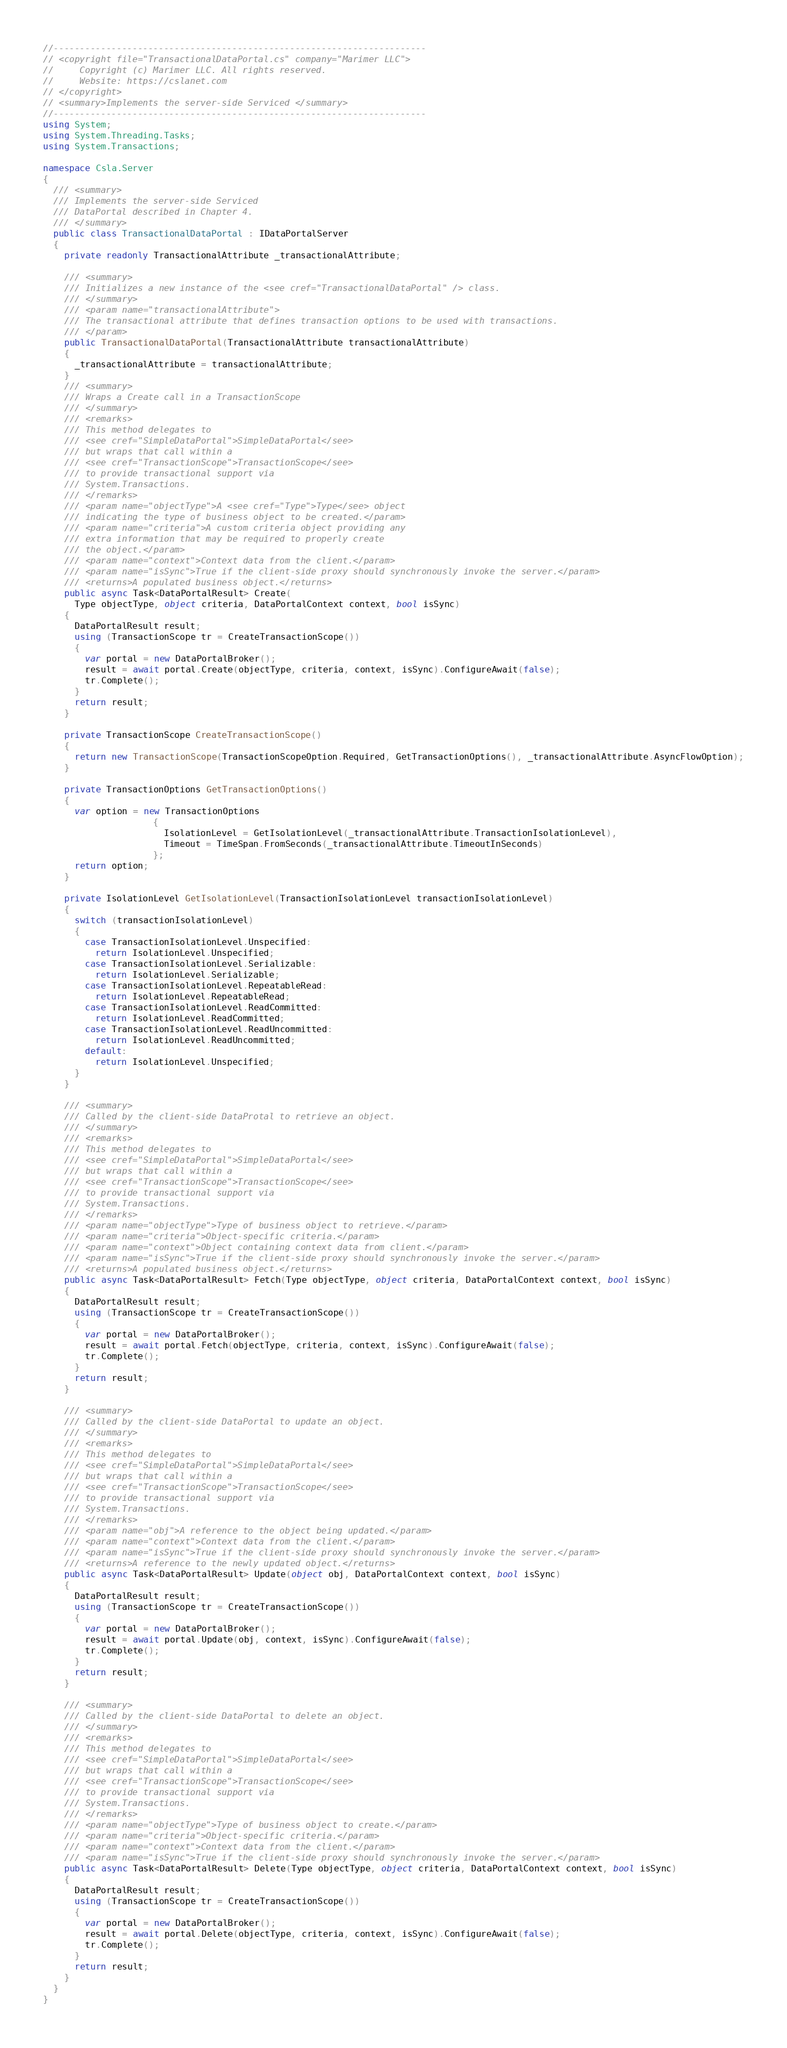Convert code to text. <code><loc_0><loc_0><loc_500><loc_500><_C#_>//-----------------------------------------------------------------------
// <copyright file="TransactionalDataPortal.cs" company="Marimer LLC">
//     Copyright (c) Marimer LLC. All rights reserved.
//     Website: https://cslanet.com
// </copyright>
// <summary>Implements the server-side Serviced </summary>
//-----------------------------------------------------------------------
using System;
using System.Threading.Tasks;
using System.Transactions;

namespace Csla.Server
{
  /// <summary>
  /// Implements the server-side Serviced 
  /// DataPortal described in Chapter 4.
  /// </summary>
  public class TransactionalDataPortal : IDataPortalServer
  {
    private readonly TransactionalAttribute _transactionalAttribute;

    /// <summary>
    /// Initializes a new instance of the <see cref="TransactionalDataPortal" /> class.
    /// </summary>
    /// <param name="transactionalAttribute">
    /// The transactional attribute that defines transaction options to be used with transactions.
    /// </param>
    public TransactionalDataPortal(TransactionalAttribute transactionalAttribute)
    {
      _transactionalAttribute = transactionalAttribute;
    }
    /// <summary>
    /// Wraps a Create call in a TransactionScope
    /// </summary>
    /// <remarks>
    /// This method delegates to 
    /// <see cref="SimpleDataPortal">SimpleDataPortal</see>
    /// but wraps that call within a
    /// <see cref="TransactionScope">TransactionScope</see>
    /// to provide transactional support via
    /// System.Transactions.
    /// </remarks>
    /// <param name="objectType">A <see cref="Type">Type</see> object
    /// indicating the type of business object to be created.</param>
    /// <param name="criteria">A custom criteria object providing any
    /// extra information that may be required to properly create
    /// the object.</param>
    /// <param name="context">Context data from the client.</param>
    /// <param name="isSync">True if the client-side proxy should synchronously invoke the server.</param>
    /// <returns>A populated business object.</returns>
    public async Task<DataPortalResult> Create(
      Type objectType, object criteria, DataPortalContext context, bool isSync)
    {
      DataPortalResult result;
      using (TransactionScope tr = CreateTransactionScope())
      {
        var portal = new DataPortalBroker();
        result = await portal.Create(objectType, criteria, context, isSync).ConfigureAwait(false);
        tr.Complete();
      }
      return result;
    }

    private TransactionScope CreateTransactionScope()
    {
      return new TransactionScope(TransactionScopeOption.Required, GetTransactionOptions(), _transactionalAttribute.AsyncFlowOption);
    }

    private TransactionOptions GetTransactionOptions()
    {
      var option = new TransactionOptions
                     {
                       IsolationLevel = GetIsolationLevel(_transactionalAttribute.TransactionIsolationLevel),
                       Timeout = TimeSpan.FromSeconds(_transactionalAttribute.TimeoutInSeconds)
                     };
      return option;
    }

    private IsolationLevel GetIsolationLevel(TransactionIsolationLevel transactionIsolationLevel)
    {
      switch (transactionIsolationLevel)
      {
        case TransactionIsolationLevel.Unspecified:
          return IsolationLevel.Unspecified;
        case TransactionIsolationLevel.Serializable:
          return IsolationLevel.Serializable;
        case TransactionIsolationLevel.RepeatableRead:
          return IsolationLevel.RepeatableRead;
        case TransactionIsolationLevel.ReadCommitted:
          return IsolationLevel.ReadCommitted;
        case TransactionIsolationLevel.ReadUncommitted:
          return IsolationLevel.ReadUncommitted;
        default:
          return IsolationLevel.Unspecified;
      }
    }

    /// <summary>
    /// Called by the client-side DataProtal to retrieve an object.
    /// </summary>
    /// <remarks>
    /// This method delegates to 
    /// <see cref="SimpleDataPortal">SimpleDataPortal</see>
    /// but wraps that call within a
    /// <see cref="TransactionScope">TransactionScope</see>
    /// to provide transactional support via
    /// System.Transactions.
    /// </remarks>
    /// <param name="objectType">Type of business object to retrieve.</param>
    /// <param name="criteria">Object-specific criteria.</param>
    /// <param name="context">Object containing context data from client.</param>
    /// <param name="isSync">True if the client-side proxy should synchronously invoke the server.</param>
    /// <returns>A populated business object.</returns>
    public async Task<DataPortalResult> Fetch(Type objectType, object criteria, DataPortalContext context, bool isSync)
    {
      DataPortalResult result;
      using (TransactionScope tr = CreateTransactionScope())
      {
        var portal = new DataPortalBroker();
        result = await portal.Fetch(objectType, criteria, context, isSync).ConfigureAwait(false);
        tr.Complete();
      }
      return result;
    }

    /// <summary>
    /// Called by the client-side DataPortal to update an object.
    /// </summary>
    /// <remarks>
    /// This method delegates to 
    /// <see cref="SimpleDataPortal">SimpleDataPortal</see>
    /// but wraps that call within a
    /// <see cref="TransactionScope">TransactionScope</see>
    /// to provide transactional support via
    /// System.Transactions.
    /// </remarks>
    /// <param name="obj">A reference to the object being updated.</param>
    /// <param name="context">Context data from the client.</param>
    /// <param name="isSync">True if the client-side proxy should synchronously invoke the server.</param>
    /// <returns>A reference to the newly updated object.</returns>
    public async Task<DataPortalResult> Update(object obj, DataPortalContext context, bool isSync)
    {
      DataPortalResult result;
      using (TransactionScope tr = CreateTransactionScope())
      {
        var portal = new DataPortalBroker();
        result = await portal.Update(obj, context, isSync).ConfigureAwait(false);
        tr.Complete();
      }
      return result;
    }

    /// <summary>
    /// Called by the client-side DataPortal to delete an object.
    /// </summary>
    /// <remarks>
    /// This method delegates to 
    /// <see cref="SimpleDataPortal">SimpleDataPortal</see>
    /// but wraps that call within a
    /// <see cref="TransactionScope">TransactionScope</see>
    /// to provide transactional support via
    /// System.Transactions.
    /// </remarks>
    /// <param name="objectType">Type of business object to create.</param>
    /// <param name="criteria">Object-specific criteria.</param>
    /// <param name="context">Context data from the client.</param>
    /// <param name="isSync">True if the client-side proxy should synchronously invoke the server.</param>
    public async Task<DataPortalResult> Delete(Type objectType, object criteria, DataPortalContext context, bool isSync)
    {
      DataPortalResult result;
      using (TransactionScope tr = CreateTransactionScope())
      {
        var portal = new DataPortalBroker();
        result = await portal.Delete(objectType, criteria, context, isSync).ConfigureAwait(false);
        tr.Complete();
      }
      return result;
    }
  }
}
</code> 